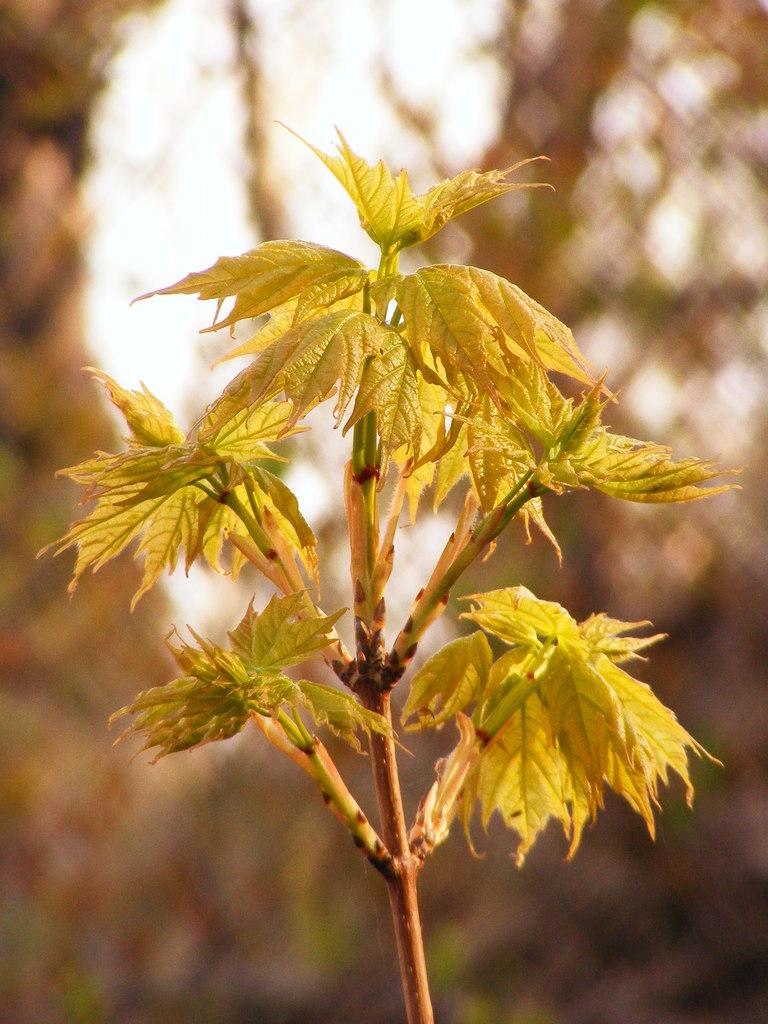In one or two sentences, can you explain what this image depicts? There is a plant which is having green color leaves. In the background, there are trees and there is sky. 